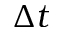Convert formula to latex. <formula><loc_0><loc_0><loc_500><loc_500>\Delta t</formula> 